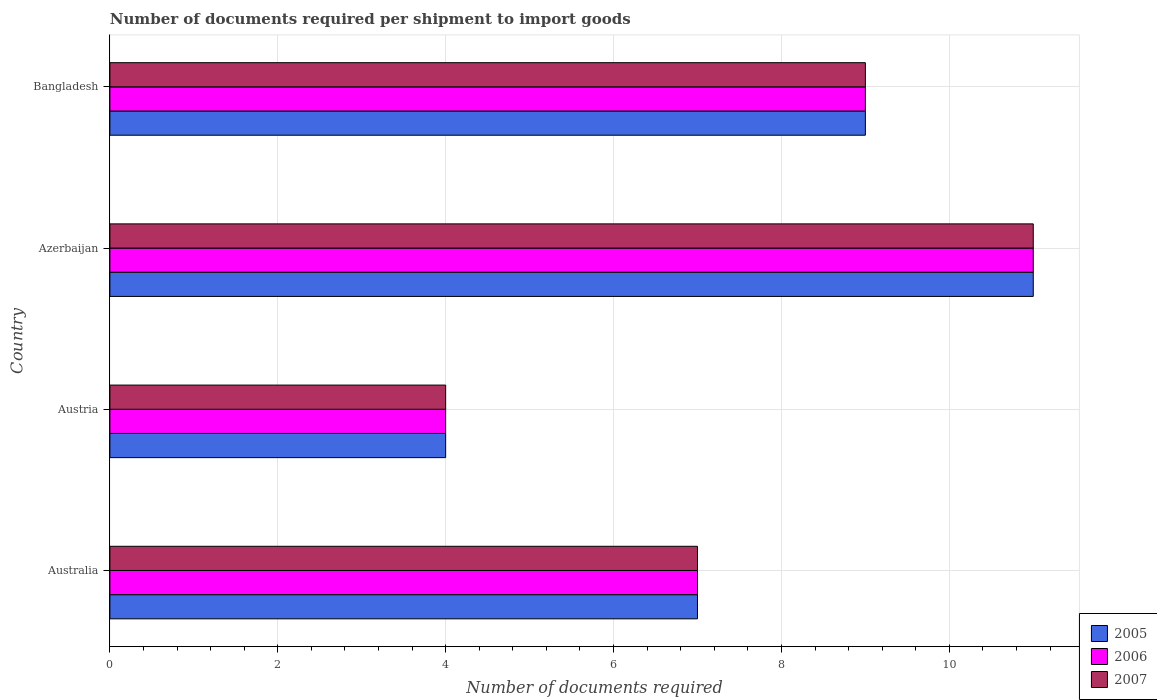How many different coloured bars are there?
Your answer should be very brief. 3. How many groups of bars are there?
Give a very brief answer. 4. How many bars are there on the 2nd tick from the top?
Ensure brevity in your answer.  3. How many bars are there on the 3rd tick from the bottom?
Your response must be concise. 3. Across all countries, what is the maximum number of documents required per shipment to import goods in 2006?
Offer a terse response. 11. Across all countries, what is the minimum number of documents required per shipment to import goods in 2006?
Give a very brief answer. 4. In which country was the number of documents required per shipment to import goods in 2007 maximum?
Ensure brevity in your answer.  Azerbaijan. In which country was the number of documents required per shipment to import goods in 2007 minimum?
Ensure brevity in your answer.  Austria. What is the difference between the number of documents required per shipment to import goods in 2007 in Australia and that in Azerbaijan?
Offer a terse response. -4. What is the average number of documents required per shipment to import goods in 2007 per country?
Give a very brief answer. 7.75. What is the difference between the number of documents required per shipment to import goods in 2006 and number of documents required per shipment to import goods in 2005 in Azerbaijan?
Ensure brevity in your answer.  0. What is the ratio of the number of documents required per shipment to import goods in 2005 in Austria to that in Bangladesh?
Keep it short and to the point. 0.44. Is the number of documents required per shipment to import goods in 2007 in Australia less than that in Azerbaijan?
Provide a succinct answer. Yes. What is the difference between the highest and the lowest number of documents required per shipment to import goods in 2007?
Your answer should be very brief. 7. In how many countries, is the number of documents required per shipment to import goods in 2006 greater than the average number of documents required per shipment to import goods in 2006 taken over all countries?
Give a very brief answer. 2. Is the sum of the number of documents required per shipment to import goods in 2007 in Australia and Bangladesh greater than the maximum number of documents required per shipment to import goods in 2006 across all countries?
Offer a terse response. Yes. What does the 1st bar from the bottom in Bangladesh represents?
Your answer should be very brief. 2005. How many bars are there?
Provide a short and direct response. 12. What is the difference between two consecutive major ticks on the X-axis?
Your answer should be compact. 2. Are the values on the major ticks of X-axis written in scientific E-notation?
Give a very brief answer. No. Where does the legend appear in the graph?
Keep it short and to the point. Bottom right. How many legend labels are there?
Offer a very short reply. 3. How are the legend labels stacked?
Offer a very short reply. Vertical. What is the title of the graph?
Give a very brief answer. Number of documents required per shipment to import goods. What is the label or title of the X-axis?
Provide a short and direct response. Number of documents required. What is the label or title of the Y-axis?
Make the answer very short. Country. What is the Number of documents required in 2007 in Australia?
Ensure brevity in your answer.  7. What is the Number of documents required in 2005 in Austria?
Offer a very short reply. 4. What is the Number of documents required of 2006 in Austria?
Ensure brevity in your answer.  4. What is the Number of documents required of 2007 in Austria?
Your answer should be compact. 4. What is the Number of documents required of 2006 in Azerbaijan?
Give a very brief answer. 11. What is the Number of documents required in 2007 in Bangladesh?
Your answer should be compact. 9. Across all countries, what is the maximum Number of documents required of 2006?
Your answer should be compact. 11. Across all countries, what is the minimum Number of documents required in 2007?
Offer a very short reply. 4. What is the total Number of documents required in 2006 in the graph?
Make the answer very short. 31. What is the total Number of documents required of 2007 in the graph?
Provide a succinct answer. 31. What is the difference between the Number of documents required of 2006 in Australia and that in Azerbaijan?
Make the answer very short. -4. What is the difference between the Number of documents required of 2007 in Australia and that in Azerbaijan?
Provide a succinct answer. -4. What is the difference between the Number of documents required in 2006 in Australia and that in Bangladesh?
Your response must be concise. -2. What is the difference between the Number of documents required of 2007 in Australia and that in Bangladesh?
Give a very brief answer. -2. What is the difference between the Number of documents required in 2006 in Austria and that in Bangladesh?
Your answer should be very brief. -5. What is the difference between the Number of documents required of 2007 in Azerbaijan and that in Bangladesh?
Your answer should be very brief. 2. What is the difference between the Number of documents required of 2005 in Australia and the Number of documents required of 2006 in Austria?
Give a very brief answer. 3. What is the difference between the Number of documents required of 2006 in Australia and the Number of documents required of 2007 in Austria?
Make the answer very short. 3. What is the difference between the Number of documents required in 2005 in Australia and the Number of documents required in 2007 in Azerbaijan?
Make the answer very short. -4. What is the difference between the Number of documents required in 2006 in Australia and the Number of documents required in 2007 in Bangladesh?
Provide a succinct answer. -2. What is the difference between the Number of documents required of 2005 in Austria and the Number of documents required of 2007 in Azerbaijan?
Offer a terse response. -7. What is the difference between the Number of documents required of 2006 in Austria and the Number of documents required of 2007 in Azerbaijan?
Give a very brief answer. -7. What is the difference between the Number of documents required in 2005 in Austria and the Number of documents required in 2007 in Bangladesh?
Ensure brevity in your answer.  -5. What is the difference between the Number of documents required of 2006 in Austria and the Number of documents required of 2007 in Bangladesh?
Give a very brief answer. -5. What is the difference between the Number of documents required of 2005 in Azerbaijan and the Number of documents required of 2007 in Bangladesh?
Your response must be concise. 2. What is the average Number of documents required of 2005 per country?
Offer a very short reply. 7.75. What is the average Number of documents required of 2006 per country?
Your response must be concise. 7.75. What is the average Number of documents required in 2007 per country?
Offer a terse response. 7.75. What is the difference between the Number of documents required of 2005 and Number of documents required of 2006 in Australia?
Give a very brief answer. 0. What is the difference between the Number of documents required in 2006 and Number of documents required in 2007 in Australia?
Provide a short and direct response. 0. What is the difference between the Number of documents required of 2006 and Number of documents required of 2007 in Austria?
Keep it short and to the point. 0. What is the difference between the Number of documents required of 2005 and Number of documents required of 2006 in Azerbaijan?
Ensure brevity in your answer.  0. What is the difference between the Number of documents required in 2005 and Number of documents required in 2007 in Azerbaijan?
Offer a very short reply. 0. What is the difference between the Number of documents required in 2006 and Number of documents required in 2007 in Bangladesh?
Make the answer very short. 0. What is the ratio of the Number of documents required of 2005 in Australia to that in Austria?
Give a very brief answer. 1.75. What is the ratio of the Number of documents required in 2007 in Australia to that in Austria?
Keep it short and to the point. 1.75. What is the ratio of the Number of documents required of 2005 in Australia to that in Azerbaijan?
Ensure brevity in your answer.  0.64. What is the ratio of the Number of documents required of 2006 in Australia to that in Azerbaijan?
Your answer should be very brief. 0.64. What is the ratio of the Number of documents required of 2007 in Australia to that in Azerbaijan?
Give a very brief answer. 0.64. What is the ratio of the Number of documents required of 2005 in Australia to that in Bangladesh?
Provide a succinct answer. 0.78. What is the ratio of the Number of documents required of 2006 in Australia to that in Bangladesh?
Provide a short and direct response. 0.78. What is the ratio of the Number of documents required of 2005 in Austria to that in Azerbaijan?
Ensure brevity in your answer.  0.36. What is the ratio of the Number of documents required of 2006 in Austria to that in Azerbaijan?
Your response must be concise. 0.36. What is the ratio of the Number of documents required of 2007 in Austria to that in Azerbaijan?
Give a very brief answer. 0.36. What is the ratio of the Number of documents required of 2005 in Austria to that in Bangladesh?
Give a very brief answer. 0.44. What is the ratio of the Number of documents required of 2006 in Austria to that in Bangladesh?
Give a very brief answer. 0.44. What is the ratio of the Number of documents required in 2007 in Austria to that in Bangladesh?
Provide a short and direct response. 0.44. What is the ratio of the Number of documents required in 2005 in Azerbaijan to that in Bangladesh?
Offer a very short reply. 1.22. What is the ratio of the Number of documents required in 2006 in Azerbaijan to that in Bangladesh?
Your answer should be very brief. 1.22. What is the ratio of the Number of documents required of 2007 in Azerbaijan to that in Bangladesh?
Give a very brief answer. 1.22. What is the difference between the highest and the second highest Number of documents required of 2006?
Provide a short and direct response. 2. What is the difference between the highest and the lowest Number of documents required of 2007?
Your response must be concise. 7. 